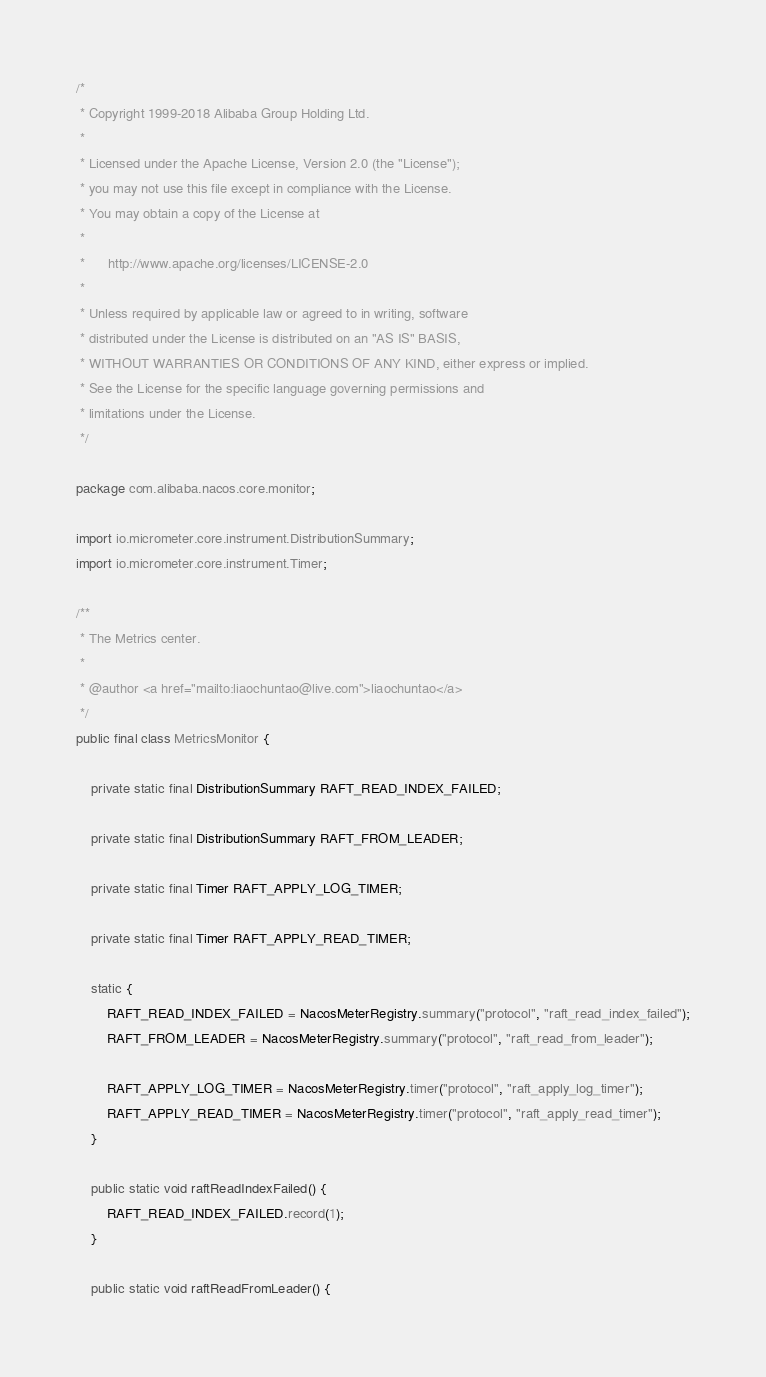<code> <loc_0><loc_0><loc_500><loc_500><_Java_>/*
 * Copyright 1999-2018 Alibaba Group Holding Ltd.
 *
 * Licensed under the Apache License, Version 2.0 (the "License");
 * you may not use this file except in compliance with the License.
 * You may obtain a copy of the License at
 *
 *      http://www.apache.org/licenses/LICENSE-2.0
 *
 * Unless required by applicable law or agreed to in writing, software
 * distributed under the License is distributed on an "AS IS" BASIS,
 * WITHOUT WARRANTIES OR CONDITIONS OF ANY KIND, either express or implied.
 * See the License for the specific language governing permissions and
 * limitations under the License.
 */

package com.alibaba.nacos.core.monitor;

import io.micrometer.core.instrument.DistributionSummary;
import io.micrometer.core.instrument.Timer;

/**
 * The Metrics center.
 *
 * @author <a href="mailto:liaochuntao@live.com">liaochuntao</a>
 */
public final class MetricsMonitor {
    
    private static final DistributionSummary RAFT_READ_INDEX_FAILED;
    
    private static final DistributionSummary RAFT_FROM_LEADER;
    
    private static final Timer RAFT_APPLY_LOG_TIMER;
    
    private static final Timer RAFT_APPLY_READ_TIMER;
    
    static {
        RAFT_READ_INDEX_FAILED = NacosMeterRegistry.summary("protocol", "raft_read_index_failed");
        RAFT_FROM_LEADER = NacosMeterRegistry.summary("protocol", "raft_read_from_leader");
        
        RAFT_APPLY_LOG_TIMER = NacosMeterRegistry.timer("protocol", "raft_apply_log_timer");
        RAFT_APPLY_READ_TIMER = NacosMeterRegistry.timer("protocol", "raft_apply_read_timer");
    }
    
    public static void raftReadIndexFailed() {
        RAFT_READ_INDEX_FAILED.record(1);
    }
    
    public static void raftReadFromLeader() {</code> 